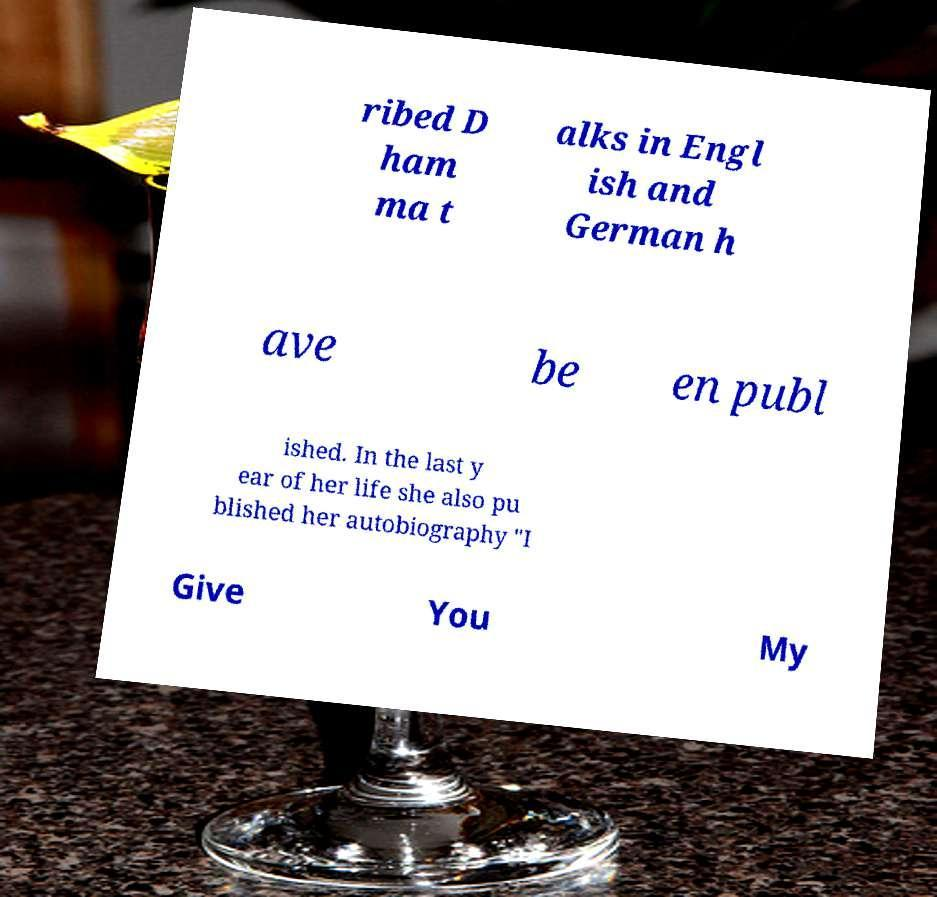Please read and relay the text visible in this image. What does it say? ribed D ham ma t alks in Engl ish and German h ave be en publ ished. In the last y ear of her life she also pu blished her autobiography "I Give You My 